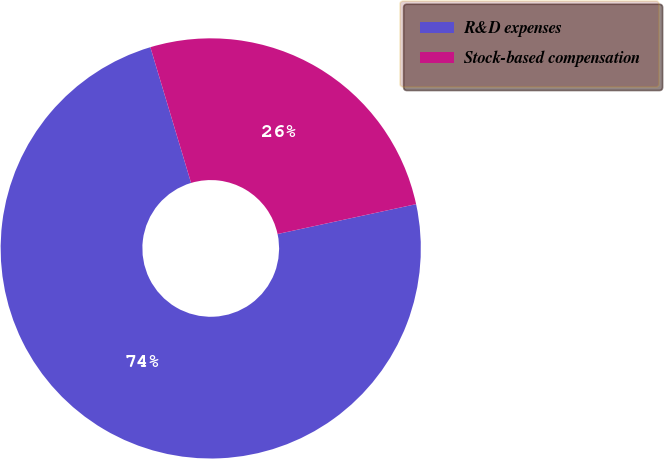Convert chart to OTSL. <chart><loc_0><loc_0><loc_500><loc_500><pie_chart><fcel>R&D expenses<fcel>Stock-based compensation<nl><fcel>73.74%<fcel>26.26%<nl></chart> 